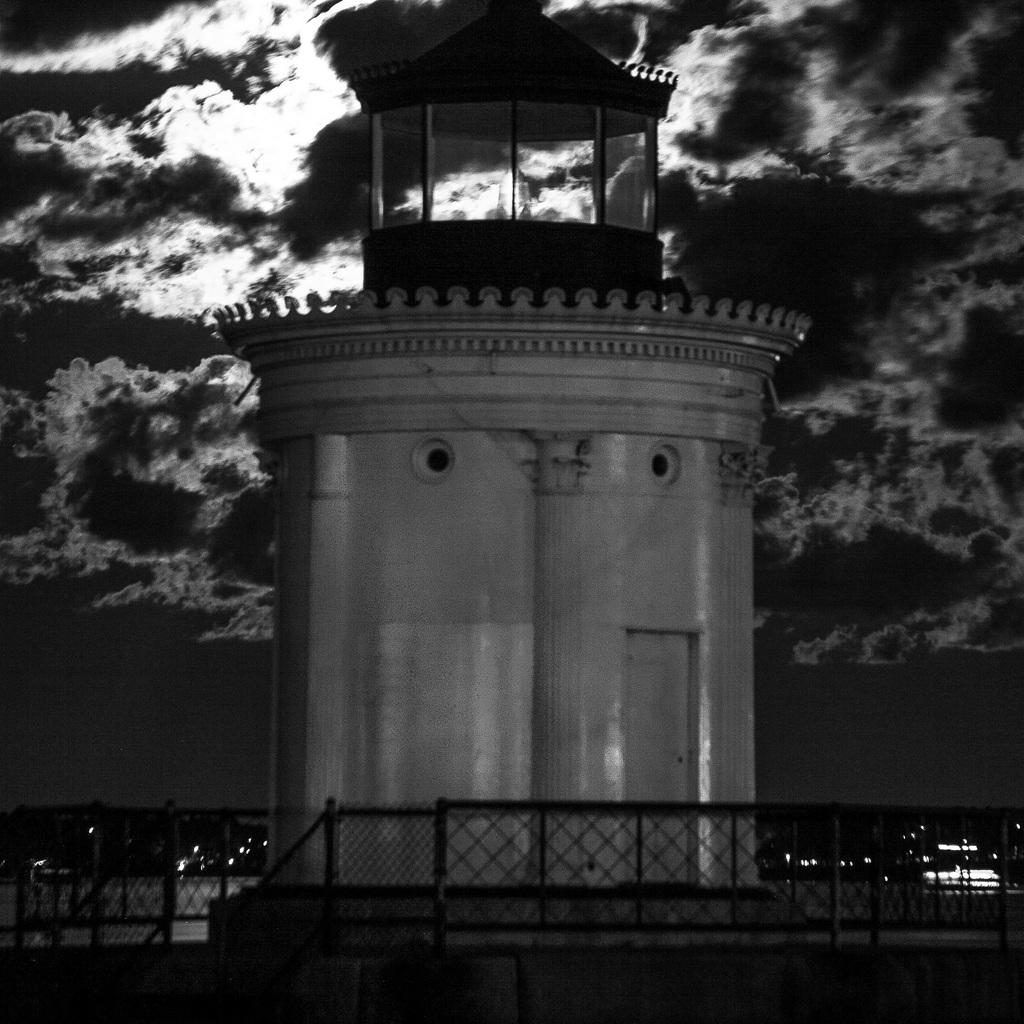What is the main structure in the image? There is a tower in the image. What feature surrounds the tower? There is a railing around the tower. What can be seen in the background of the image? The sky is visible in the background of the image. What type of teeth can be seen on the tower in the image? There are no teeth present on the tower in the image. 